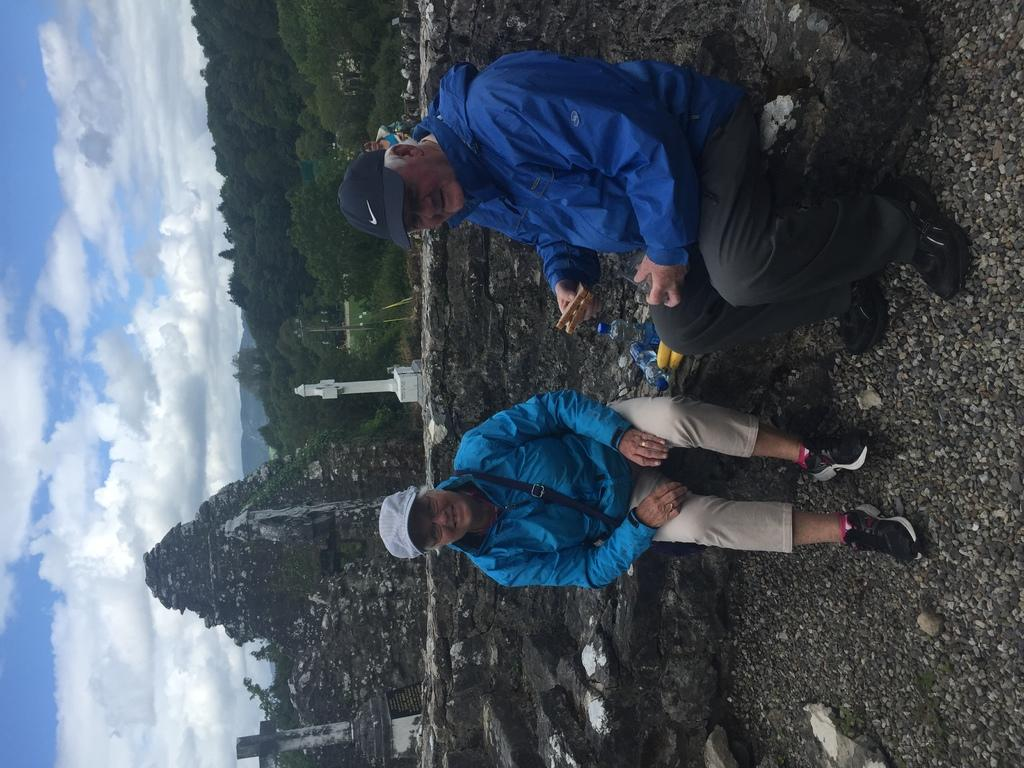What are the people in the image doing? The persons in the image are sitting at the wall in the center of the image. What can be seen in the background of the image? In the background of the image, there is a pillar, hills, trees, buildings, and the sky. What is the condition of the sky in the image? The sky is visible in the background of the image, and clouds are present. What type of magic is being performed by the persons sitting at the wall in the image? There is no indication of magic or any magical activity in the image. The persons are simply sitting at the wall. How much dust can be seen on the buildings in the background of the image? There is no mention of dust in the image, and the condition of the buildings is not described. 